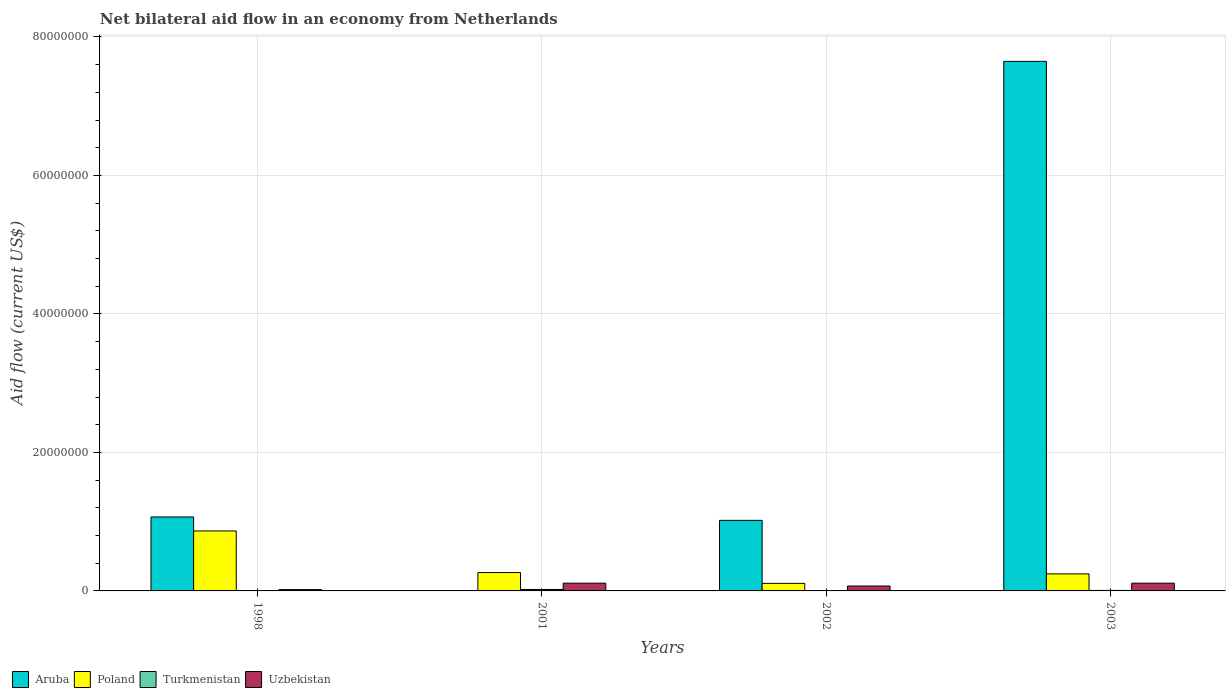How many different coloured bars are there?
Your answer should be very brief. 4. Are the number of bars per tick equal to the number of legend labels?
Keep it short and to the point. No. How many bars are there on the 4th tick from the left?
Your answer should be very brief. 4. How many bars are there on the 2nd tick from the right?
Provide a short and direct response. 4. In how many cases, is the number of bars for a given year not equal to the number of legend labels?
Provide a short and direct response. 1. What is the net bilateral aid flow in Turkmenistan in 2003?
Ensure brevity in your answer.  7.00e+04. Across all years, what is the maximum net bilateral aid flow in Aruba?
Your answer should be very brief. 7.65e+07. What is the total net bilateral aid flow in Aruba in the graph?
Make the answer very short. 9.73e+07. What is the difference between the net bilateral aid flow in Poland in 2001 and that in 2003?
Give a very brief answer. 1.90e+05. What is the difference between the net bilateral aid flow in Aruba in 1998 and the net bilateral aid flow in Poland in 2002?
Provide a short and direct response. 9.59e+06. What is the average net bilateral aid flow in Aruba per year?
Offer a very short reply. 2.43e+07. In the year 1998, what is the difference between the net bilateral aid flow in Aruba and net bilateral aid flow in Turkmenistan?
Keep it short and to the point. 1.07e+07. In how many years, is the net bilateral aid flow in Aruba greater than 32000000 US$?
Provide a short and direct response. 1. What is the ratio of the net bilateral aid flow in Uzbekistan in 2001 to that in 2002?
Your response must be concise. 1.58. What is the difference between the highest and the second highest net bilateral aid flow in Aruba?
Keep it short and to the point. 6.58e+07. What is the difference between the highest and the lowest net bilateral aid flow in Turkmenistan?
Your answer should be compact. 2.00e+05. Is it the case that in every year, the sum of the net bilateral aid flow in Aruba and net bilateral aid flow in Turkmenistan is greater than the sum of net bilateral aid flow in Poland and net bilateral aid flow in Uzbekistan?
Your answer should be very brief. Yes. How many bars are there?
Provide a succinct answer. 15. Are all the bars in the graph horizontal?
Your answer should be compact. No. How many years are there in the graph?
Your response must be concise. 4. Are the values on the major ticks of Y-axis written in scientific E-notation?
Provide a short and direct response. No. Does the graph contain grids?
Your answer should be compact. Yes. What is the title of the graph?
Offer a very short reply. Net bilateral aid flow in an economy from Netherlands. What is the label or title of the X-axis?
Offer a terse response. Years. What is the Aid flow (current US$) in Aruba in 1998?
Give a very brief answer. 1.07e+07. What is the Aid flow (current US$) in Poland in 1998?
Provide a succinct answer. 8.66e+06. What is the Aid flow (current US$) of Turkmenistan in 1998?
Make the answer very short. 10000. What is the Aid flow (current US$) in Aruba in 2001?
Your answer should be compact. 0. What is the Aid flow (current US$) of Poland in 2001?
Make the answer very short. 2.65e+06. What is the Aid flow (current US$) in Uzbekistan in 2001?
Ensure brevity in your answer.  1.12e+06. What is the Aid flow (current US$) of Aruba in 2002?
Your response must be concise. 1.02e+07. What is the Aid flow (current US$) in Poland in 2002?
Provide a short and direct response. 1.09e+06. What is the Aid flow (current US$) in Turkmenistan in 2002?
Give a very brief answer. 4.00e+04. What is the Aid flow (current US$) of Uzbekistan in 2002?
Ensure brevity in your answer.  7.10e+05. What is the Aid flow (current US$) in Aruba in 2003?
Ensure brevity in your answer.  7.65e+07. What is the Aid flow (current US$) of Poland in 2003?
Keep it short and to the point. 2.46e+06. What is the Aid flow (current US$) of Turkmenistan in 2003?
Make the answer very short. 7.00e+04. What is the Aid flow (current US$) of Uzbekistan in 2003?
Offer a terse response. 1.12e+06. Across all years, what is the maximum Aid flow (current US$) in Aruba?
Provide a succinct answer. 7.65e+07. Across all years, what is the maximum Aid flow (current US$) in Poland?
Offer a terse response. 8.66e+06. Across all years, what is the maximum Aid flow (current US$) of Uzbekistan?
Your answer should be compact. 1.12e+06. Across all years, what is the minimum Aid flow (current US$) of Aruba?
Offer a terse response. 0. Across all years, what is the minimum Aid flow (current US$) in Poland?
Provide a short and direct response. 1.09e+06. Across all years, what is the minimum Aid flow (current US$) in Turkmenistan?
Make the answer very short. 10000. Across all years, what is the minimum Aid flow (current US$) in Uzbekistan?
Offer a terse response. 1.90e+05. What is the total Aid flow (current US$) of Aruba in the graph?
Provide a succinct answer. 9.73e+07. What is the total Aid flow (current US$) in Poland in the graph?
Keep it short and to the point. 1.49e+07. What is the total Aid flow (current US$) of Uzbekistan in the graph?
Keep it short and to the point. 3.14e+06. What is the difference between the Aid flow (current US$) of Poland in 1998 and that in 2001?
Keep it short and to the point. 6.01e+06. What is the difference between the Aid flow (current US$) in Uzbekistan in 1998 and that in 2001?
Offer a very short reply. -9.30e+05. What is the difference between the Aid flow (current US$) in Poland in 1998 and that in 2002?
Your response must be concise. 7.57e+06. What is the difference between the Aid flow (current US$) of Uzbekistan in 1998 and that in 2002?
Ensure brevity in your answer.  -5.20e+05. What is the difference between the Aid flow (current US$) in Aruba in 1998 and that in 2003?
Your answer should be compact. -6.58e+07. What is the difference between the Aid flow (current US$) in Poland in 1998 and that in 2003?
Provide a succinct answer. 6.20e+06. What is the difference between the Aid flow (current US$) of Uzbekistan in 1998 and that in 2003?
Offer a very short reply. -9.30e+05. What is the difference between the Aid flow (current US$) in Poland in 2001 and that in 2002?
Ensure brevity in your answer.  1.56e+06. What is the difference between the Aid flow (current US$) in Turkmenistan in 2001 and that in 2002?
Provide a short and direct response. 1.70e+05. What is the difference between the Aid flow (current US$) of Poland in 2001 and that in 2003?
Your answer should be compact. 1.90e+05. What is the difference between the Aid flow (current US$) in Aruba in 2002 and that in 2003?
Provide a short and direct response. -6.63e+07. What is the difference between the Aid flow (current US$) in Poland in 2002 and that in 2003?
Your response must be concise. -1.37e+06. What is the difference between the Aid flow (current US$) in Uzbekistan in 2002 and that in 2003?
Provide a succinct answer. -4.10e+05. What is the difference between the Aid flow (current US$) of Aruba in 1998 and the Aid flow (current US$) of Poland in 2001?
Offer a terse response. 8.03e+06. What is the difference between the Aid flow (current US$) in Aruba in 1998 and the Aid flow (current US$) in Turkmenistan in 2001?
Your answer should be very brief. 1.05e+07. What is the difference between the Aid flow (current US$) of Aruba in 1998 and the Aid flow (current US$) of Uzbekistan in 2001?
Your answer should be very brief. 9.56e+06. What is the difference between the Aid flow (current US$) of Poland in 1998 and the Aid flow (current US$) of Turkmenistan in 2001?
Your response must be concise. 8.45e+06. What is the difference between the Aid flow (current US$) of Poland in 1998 and the Aid flow (current US$) of Uzbekistan in 2001?
Provide a succinct answer. 7.54e+06. What is the difference between the Aid flow (current US$) of Turkmenistan in 1998 and the Aid flow (current US$) of Uzbekistan in 2001?
Keep it short and to the point. -1.11e+06. What is the difference between the Aid flow (current US$) of Aruba in 1998 and the Aid flow (current US$) of Poland in 2002?
Give a very brief answer. 9.59e+06. What is the difference between the Aid flow (current US$) in Aruba in 1998 and the Aid flow (current US$) in Turkmenistan in 2002?
Give a very brief answer. 1.06e+07. What is the difference between the Aid flow (current US$) in Aruba in 1998 and the Aid flow (current US$) in Uzbekistan in 2002?
Offer a terse response. 9.97e+06. What is the difference between the Aid flow (current US$) in Poland in 1998 and the Aid flow (current US$) in Turkmenistan in 2002?
Ensure brevity in your answer.  8.62e+06. What is the difference between the Aid flow (current US$) in Poland in 1998 and the Aid flow (current US$) in Uzbekistan in 2002?
Your response must be concise. 7.95e+06. What is the difference between the Aid flow (current US$) in Turkmenistan in 1998 and the Aid flow (current US$) in Uzbekistan in 2002?
Offer a very short reply. -7.00e+05. What is the difference between the Aid flow (current US$) of Aruba in 1998 and the Aid flow (current US$) of Poland in 2003?
Your answer should be compact. 8.22e+06. What is the difference between the Aid flow (current US$) of Aruba in 1998 and the Aid flow (current US$) of Turkmenistan in 2003?
Provide a succinct answer. 1.06e+07. What is the difference between the Aid flow (current US$) of Aruba in 1998 and the Aid flow (current US$) of Uzbekistan in 2003?
Your answer should be compact. 9.56e+06. What is the difference between the Aid flow (current US$) of Poland in 1998 and the Aid flow (current US$) of Turkmenistan in 2003?
Your answer should be very brief. 8.59e+06. What is the difference between the Aid flow (current US$) in Poland in 1998 and the Aid flow (current US$) in Uzbekistan in 2003?
Give a very brief answer. 7.54e+06. What is the difference between the Aid flow (current US$) of Turkmenistan in 1998 and the Aid flow (current US$) of Uzbekistan in 2003?
Keep it short and to the point. -1.11e+06. What is the difference between the Aid flow (current US$) in Poland in 2001 and the Aid flow (current US$) in Turkmenistan in 2002?
Ensure brevity in your answer.  2.61e+06. What is the difference between the Aid flow (current US$) in Poland in 2001 and the Aid flow (current US$) in Uzbekistan in 2002?
Give a very brief answer. 1.94e+06. What is the difference between the Aid flow (current US$) of Turkmenistan in 2001 and the Aid flow (current US$) of Uzbekistan in 2002?
Offer a very short reply. -5.00e+05. What is the difference between the Aid flow (current US$) in Poland in 2001 and the Aid flow (current US$) in Turkmenistan in 2003?
Your response must be concise. 2.58e+06. What is the difference between the Aid flow (current US$) in Poland in 2001 and the Aid flow (current US$) in Uzbekistan in 2003?
Offer a very short reply. 1.53e+06. What is the difference between the Aid flow (current US$) in Turkmenistan in 2001 and the Aid flow (current US$) in Uzbekistan in 2003?
Give a very brief answer. -9.10e+05. What is the difference between the Aid flow (current US$) of Aruba in 2002 and the Aid flow (current US$) of Poland in 2003?
Give a very brief answer. 7.73e+06. What is the difference between the Aid flow (current US$) of Aruba in 2002 and the Aid flow (current US$) of Turkmenistan in 2003?
Ensure brevity in your answer.  1.01e+07. What is the difference between the Aid flow (current US$) in Aruba in 2002 and the Aid flow (current US$) in Uzbekistan in 2003?
Keep it short and to the point. 9.07e+06. What is the difference between the Aid flow (current US$) of Poland in 2002 and the Aid flow (current US$) of Turkmenistan in 2003?
Your answer should be compact. 1.02e+06. What is the difference between the Aid flow (current US$) of Poland in 2002 and the Aid flow (current US$) of Uzbekistan in 2003?
Make the answer very short. -3.00e+04. What is the difference between the Aid flow (current US$) in Turkmenistan in 2002 and the Aid flow (current US$) in Uzbekistan in 2003?
Make the answer very short. -1.08e+06. What is the average Aid flow (current US$) of Aruba per year?
Ensure brevity in your answer.  2.43e+07. What is the average Aid flow (current US$) of Poland per year?
Keep it short and to the point. 3.72e+06. What is the average Aid flow (current US$) in Turkmenistan per year?
Offer a terse response. 8.25e+04. What is the average Aid flow (current US$) of Uzbekistan per year?
Offer a terse response. 7.85e+05. In the year 1998, what is the difference between the Aid flow (current US$) in Aruba and Aid flow (current US$) in Poland?
Provide a short and direct response. 2.02e+06. In the year 1998, what is the difference between the Aid flow (current US$) of Aruba and Aid flow (current US$) of Turkmenistan?
Provide a succinct answer. 1.07e+07. In the year 1998, what is the difference between the Aid flow (current US$) of Aruba and Aid flow (current US$) of Uzbekistan?
Offer a very short reply. 1.05e+07. In the year 1998, what is the difference between the Aid flow (current US$) in Poland and Aid flow (current US$) in Turkmenistan?
Offer a terse response. 8.65e+06. In the year 1998, what is the difference between the Aid flow (current US$) in Poland and Aid flow (current US$) in Uzbekistan?
Your answer should be very brief. 8.47e+06. In the year 1998, what is the difference between the Aid flow (current US$) in Turkmenistan and Aid flow (current US$) in Uzbekistan?
Your answer should be very brief. -1.80e+05. In the year 2001, what is the difference between the Aid flow (current US$) of Poland and Aid flow (current US$) of Turkmenistan?
Ensure brevity in your answer.  2.44e+06. In the year 2001, what is the difference between the Aid flow (current US$) in Poland and Aid flow (current US$) in Uzbekistan?
Provide a succinct answer. 1.53e+06. In the year 2001, what is the difference between the Aid flow (current US$) in Turkmenistan and Aid flow (current US$) in Uzbekistan?
Make the answer very short. -9.10e+05. In the year 2002, what is the difference between the Aid flow (current US$) of Aruba and Aid flow (current US$) of Poland?
Your answer should be very brief. 9.10e+06. In the year 2002, what is the difference between the Aid flow (current US$) in Aruba and Aid flow (current US$) in Turkmenistan?
Your response must be concise. 1.02e+07. In the year 2002, what is the difference between the Aid flow (current US$) of Aruba and Aid flow (current US$) of Uzbekistan?
Your answer should be very brief. 9.48e+06. In the year 2002, what is the difference between the Aid flow (current US$) in Poland and Aid flow (current US$) in Turkmenistan?
Offer a terse response. 1.05e+06. In the year 2002, what is the difference between the Aid flow (current US$) in Turkmenistan and Aid flow (current US$) in Uzbekistan?
Offer a terse response. -6.70e+05. In the year 2003, what is the difference between the Aid flow (current US$) of Aruba and Aid flow (current US$) of Poland?
Make the answer very short. 7.40e+07. In the year 2003, what is the difference between the Aid flow (current US$) in Aruba and Aid flow (current US$) in Turkmenistan?
Provide a short and direct response. 7.64e+07. In the year 2003, what is the difference between the Aid flow (current US$) in Aruba and Aid flow (current US$) in Uzbekistan?
Your answer should be very brief. 7.54e+07. In the year 2003, what is the difference between the Aid flow (current US$) of Poland and Aid flow (current US$) of Turkmenistan?
Provide a succinct answer. 2.39e+06. In the year 2003, what is the difference between the Aid flow (current US$) in Poland and Aid flow (current US$) in Uzbekistan?
Offer a terse response. 1.34e+06. In the year 2003, what is the difference between the Aid flow (current US$) in Turkmenistan and Aid flow (current US$) in Uzbekistan?
Provide a succinct answer. -1.05e+06. What is the ratio of the Aid flow (current US$) of Poland in 1998 to that in 2001?
Give a very brief answer. 3.27. What is the ratio of the Aid flow (current US$) in Turkmenistan in 1998 to that in 2001?
Your answer should be compact. 0.05. What is the ratio of the Aid flow (current US$) of Uzbekistan in 1998 to that in 2001?
Offer a very short reply. 0.17. What is the ratio of the Aid flow (current US$) in Aruba in 1998 to that in 2002?
Offer a terse response. 1.05. What is the ratio of the Aid flow (current US$) of Poland in 1998 to that in 2002?
Make the answer very short. 7.95. What is the ratio of the Aid flow (current US$) in Uzbekistan in 1998 to that in 2002?
Offer a terse response. 0.27. What is the ratio of the Aid flow (current US$) in Aruba in 1998 to that in 2003?
Offer a very short reply. 0.14. What is the ratio of the Aid flow (current US$) in Poland in 1998 to that in 2003?
Offer a very short reply. 3.52. What is the ratio of the Aid flow (current US$) of Turkmenistan in 1998 to that in 2003?
Give a very brief answer. 0.14. What is the ratio of the Aid flow (current US$) of Uzbekistan in 1998 to that in 2003?
Your answer should be very brief. 0.17. What is the ratio of the Aid flow (current US$) of Poland in 2001 to that in 2002?
Your response must be concise. 2.43. What is the ratio of the Aid flow (current US$) of Turkmenistan in 2001 to that in 2002?
Ensure brevity in your answer.  5.25. What is the ratio of the Aid flow (current US$) of Uzbekistan in 2001 to that in 2002?
Provide a short and direct response. 1.58. What is the ratio of the Aid flow (current US$) in Poland in 2001 to that in 2003?
Your answer should be compact. 1.08. What is the ratio of the Aid flow (current US$) in Aruba in 2002 to that in 2003?
Give a very brief answer. 0.13. What is the ratio of the Aid flow (current US$) in Poland in 2002 to that in 2003?
Provide a short and direct response. 0.44. What is the ratio of the Aid flow (current US$) of Uzbekistan in 2002 to that in 2003?
Offer a terse response. 0.63. What is the difference between the highest and the second highest Aid flow (current US$) in Aruba?
Ensure brevity in your answer.  6.58e+07. What is the difference between the highest and the second highest Aid flow (current US$) of Poland?
Ensure brevity in your answer.  6.01e+06. What is the difference between the highest and the second highest Aid flow (current US$) of Uzbekistan?
Offer a very short reply. 0. What is the difference between the highest and the lowest Aid flow (current US$) in Aruba?
Make the answer very short. 7.65e+07. What is the difference between the highest and the lowest Aid flow (current US$) of Poland?
Ensure brevity in your answer.  7.57e+06. What is the difference between the highest and the lowest Aid flow (current US$) of Turkmenistan?
Offer a very short reply. 2.00e+05. What is the difference between the highest and the lowest Aid flow (current US$) in Uzbekistan?
Make the answer very short. 9.30e+05. 